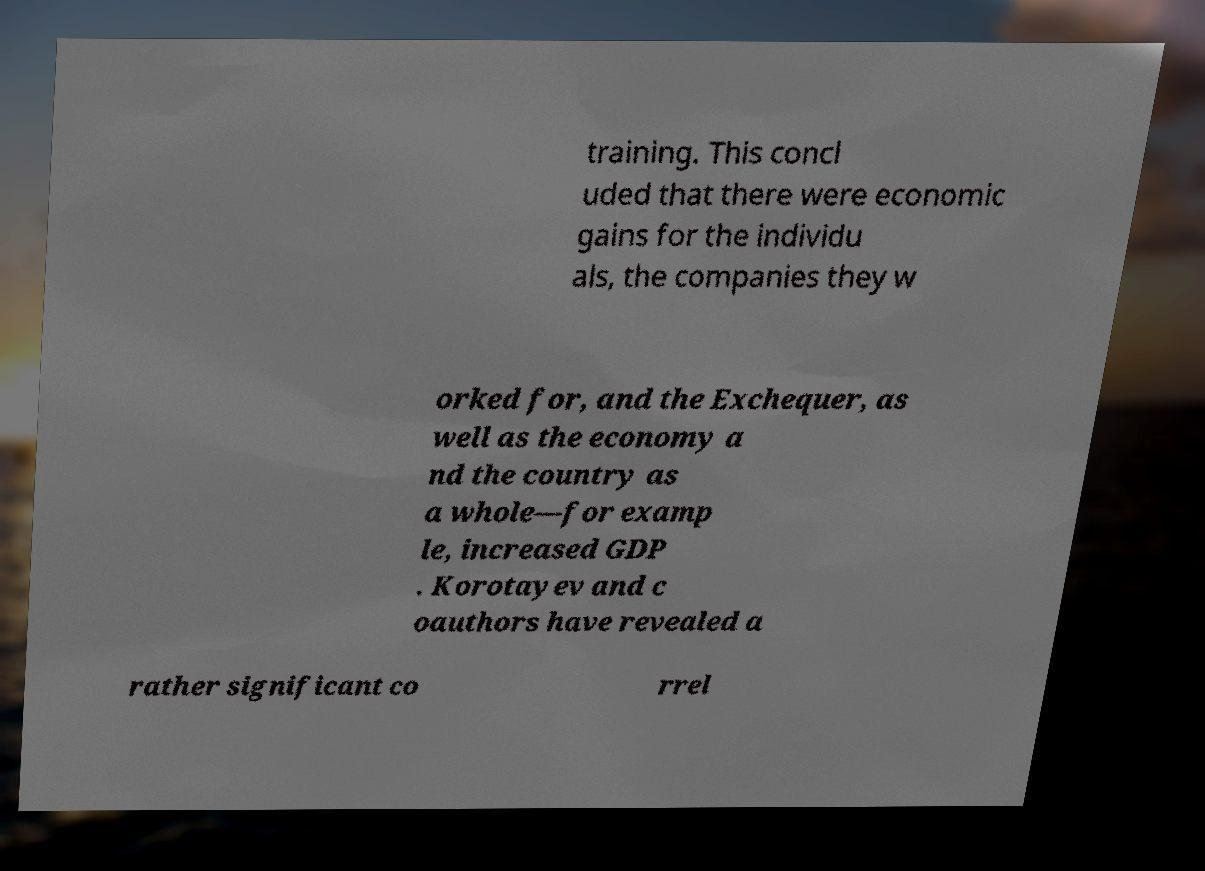For documentation purposes, I need the text within this image transcribed. Could you provide that? training. This concl uded that there were economic gains for the individu als, the companies they w orked for, and the Exchequer, as well as the economy a nd the country as a whole—for examp le, increased GDP . Korotayev and c oauthors have revealed a rather significant co rrel 